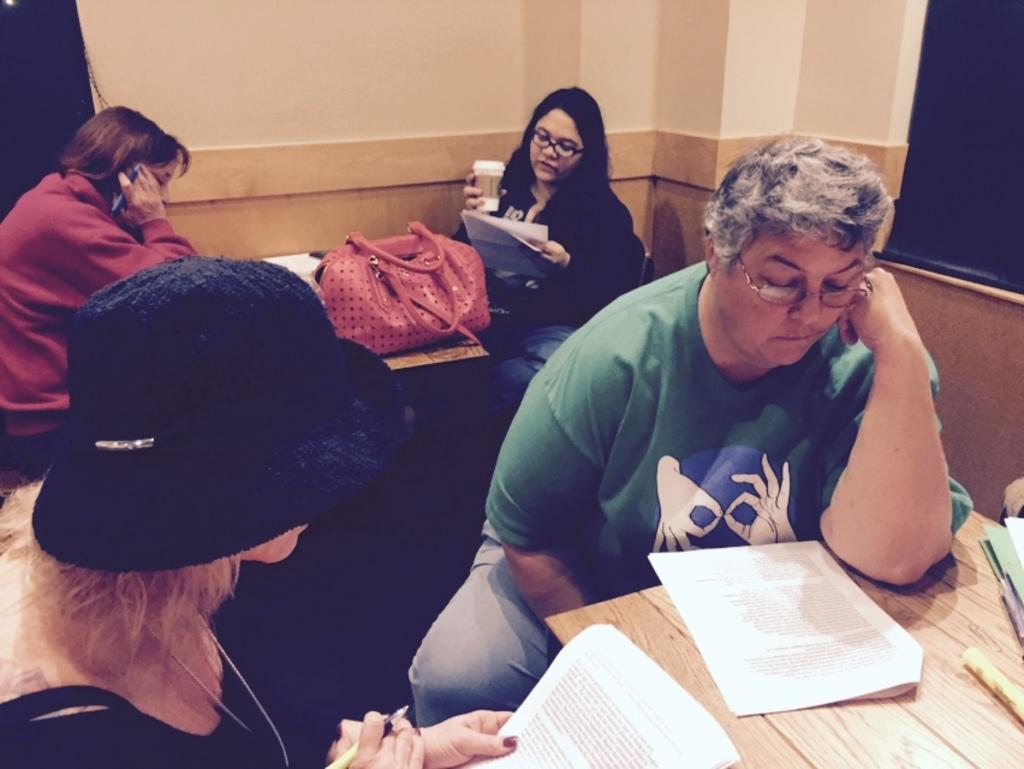How many people are present in the image? There are people in the image, but the exact number is not specified. What is the bag used for in the image? The purpose of the bag is not clear from the image. What are the papers used for in the image? The purpose of the papers is not clear from the image. What types of objects can be seen on the tables in the image? The specific objects on the tables are not mentioned, but there are objects present. What is the color of the objects in the background of the image? The objects in the background of the image are black. Can you tell me how many dogs are visible in the image? There are no dogs present in the image. What type of orange is being used as a decoration in the image? There is no orange present in the image. 